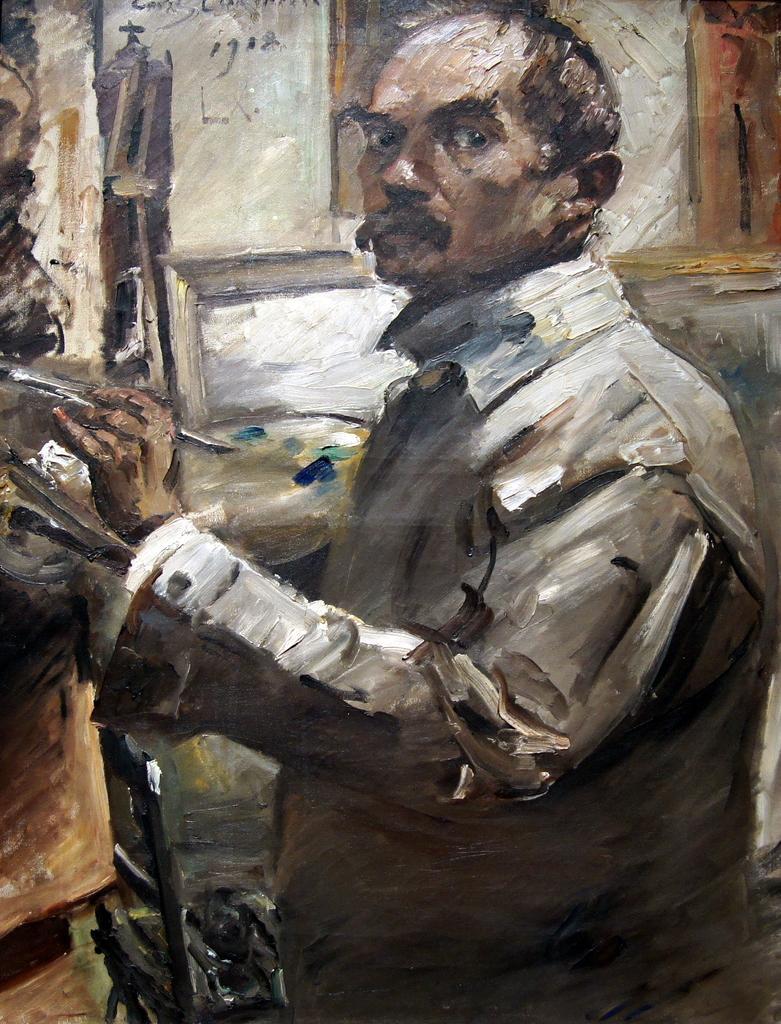In one or two sentences, can you explain what this image depicts? In this image we can see the painting of a person holding the object and the background is not clear. 